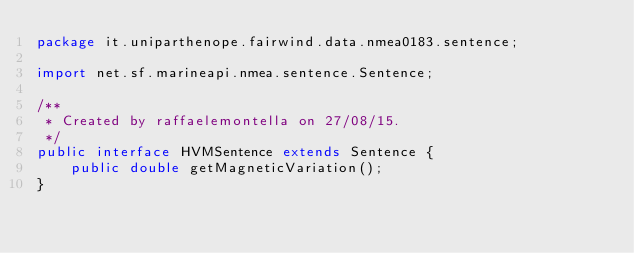Convert code to text. <code><loc_0><loc_0><loc_500><loc_500><_Java_>package it.uniparthenope.fairwind.data.nmea0183.sentence;

import net.sf.marineapi.nmea.sentence.Sentence;

/**
 * Created by raffaelemontella on 27/08/15.
 */
public interface HVMSentence extends Sentence {
    public double getMagneticVariation();
}
</code> 